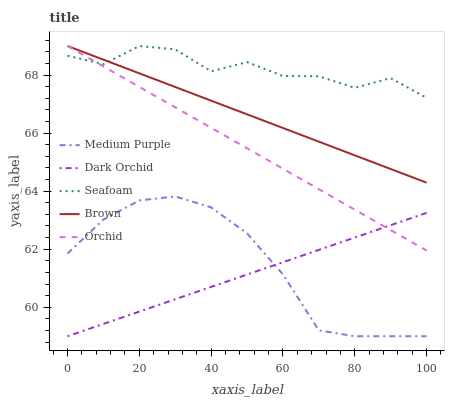Does Dark Orchid have the minimum area under the curve?
Answer yes or no. Yes. Does Seafoam have the maximum area under the curve?
Answer yes or no. Yes. Does Brown have the minimum area under the curve?
Answer yes or no. No. Does Brown have the maximum area under the curve?
Answer yes or no. No. Is Brown the smoothest?
Answer yes or no. Yes. Is Seafoam the roughest?
Answer yes or no. Yes. Is Seafoam the smoothest?
Answer yes or no. No. Is Brown the roughest?
Answer yes or no. No. Does Medium Purple have the lowest value?
Answer yes or no. Yes. Does Brown have the lowest value?
Answer yes or no. No. Does Orchid have the highest value?
Answer yes or no. Yes. Does Dark Orchid have the highest value?
Answer yes or no. No. Is Medium Purple less than Orchid?
Answer yes or no. Yes. Is Brown greater than Medium Purple?
Answer yes or no. Yes. Does Brown intersect Orchid?
Answer yes or no. Yes. Is Brown less than Orchid?
Answer yes or no. No. Is Brown greater than Orchid?
Answer yes or no. No. Does Medium Purple intersect Orchid?
Answer yes or no. No. 